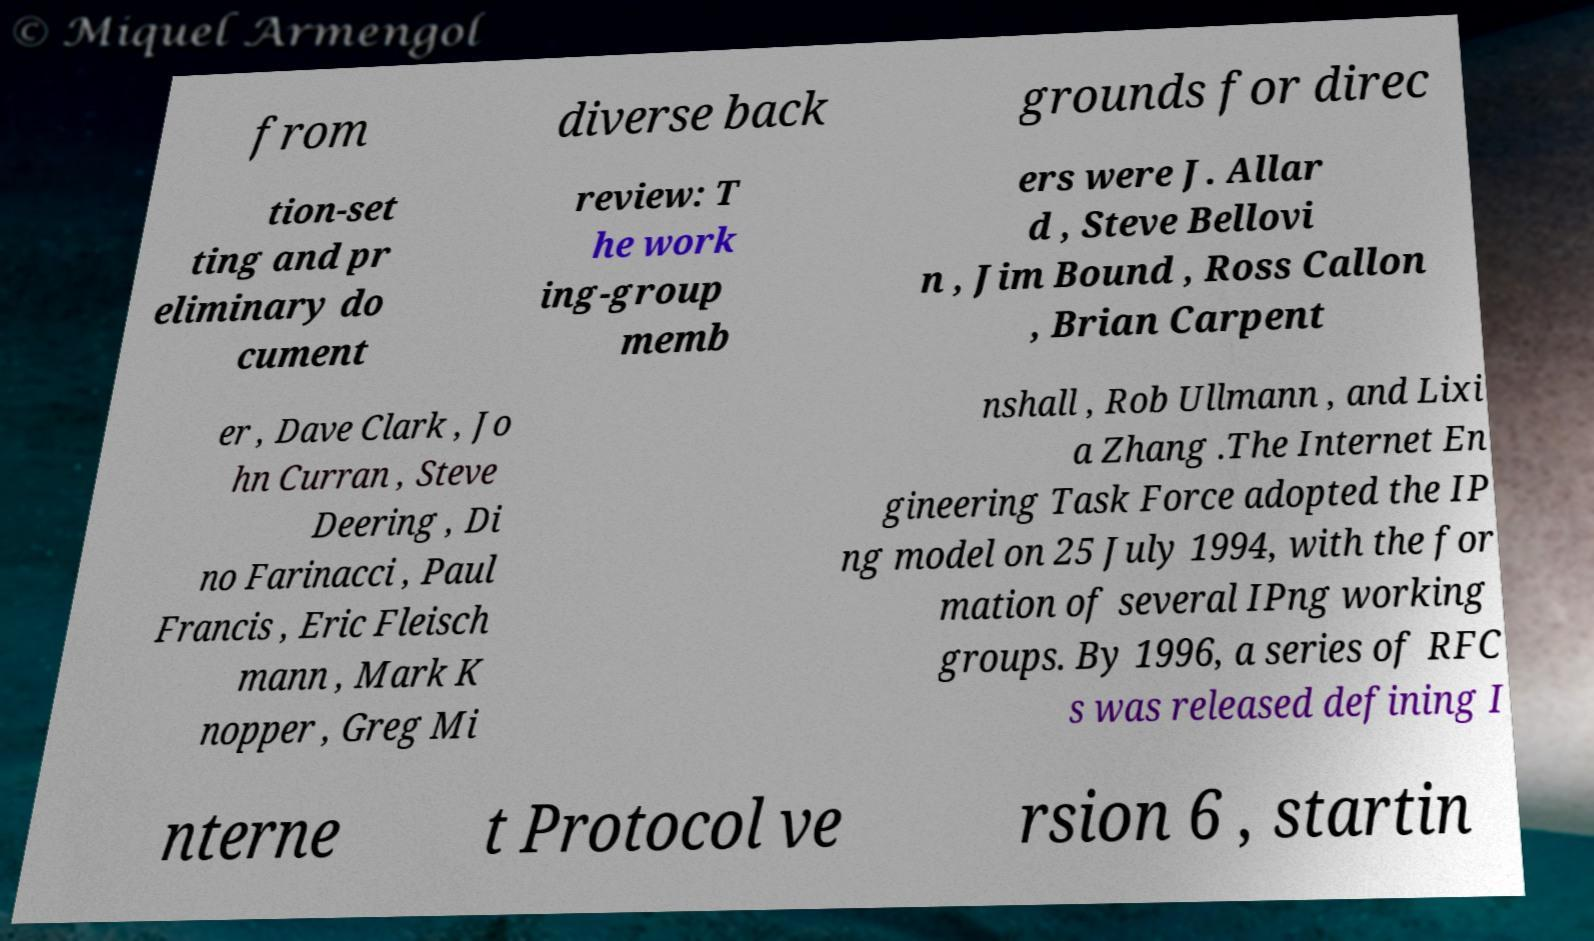I need the written content from this picture converted into text. Can you do that? from diverse back grounds for direc tion-set ting and pr eliminary do cument review: T he work ing-group memb ers were J. Allar d , Steve Bellovi n , Jim Bound , Ross Callon , Brian Carpent er , Dave Clark , Jo hn Curran , Steve Deering , Di no Farinacci , Paul Francis , Eric Fleisch mann , Mark K nopper , Greg Mi nshall , Rob Ullmann , and Lixi a Zhang .The Internet En gineering Task Force adopted the IP ng model on 25 July 1994, with the for mation of several IPng working groups. By 1996, a series of RFC s was released defining I nterne t Protocol ve rsion 6 , startin 